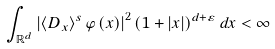<formula> <loc_0><loc_0><loc_500><loc_500>\int _ { \mathbb { R } ^ { d } } \left | \left \langle D _ { x } \right \rangle ^ { s } \varphi \left ( x \right ) \right | ^ { 2 } \left ( 1 + \left | x \right | \right ) ^ { d + \varepsilon } d x < \infty</formula> 